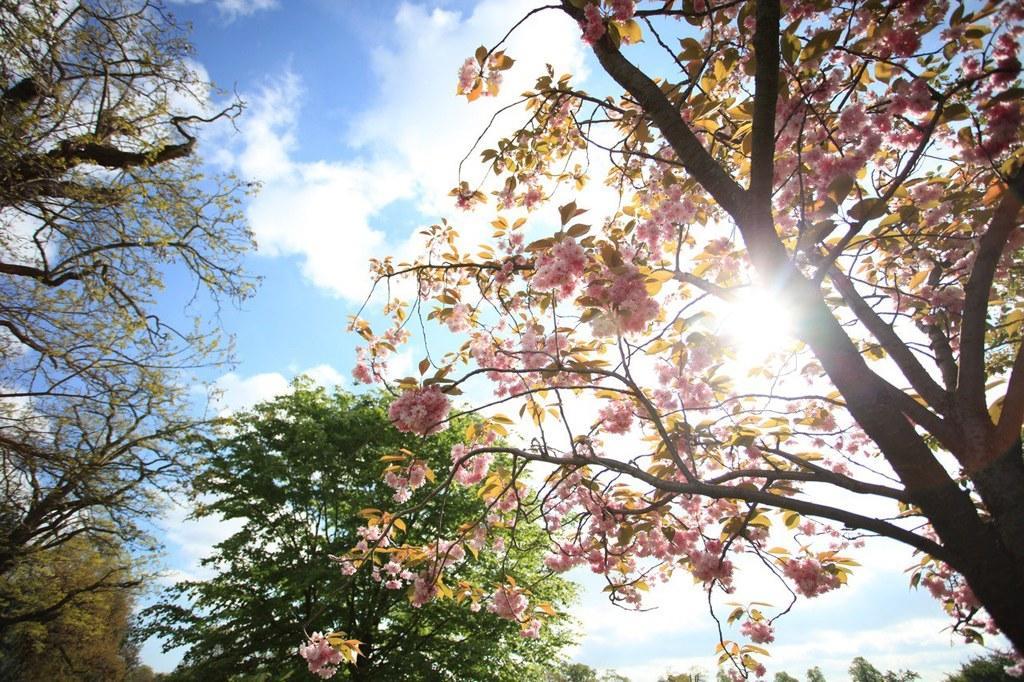Can you describe this image briefly? In this image there are trees on top there is sky. 